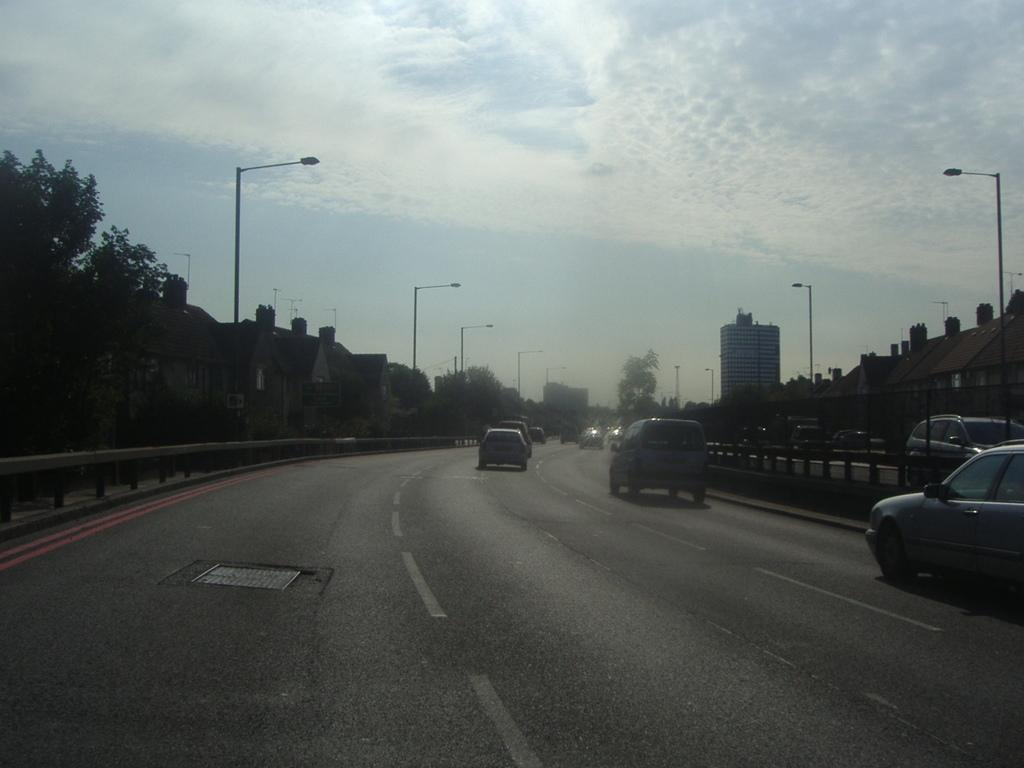What is happening on the road in the image? Vehicles are moving on the road. What can be seen in the background of the image? There are trees, plants, buildings, street lights, vehicles, and the sky visible in the background. Can you describe the setting of the image? The image shows a road with vehicles moving, surrounded by trees, plants, buildings, and street lights in the background, with the sky visible above. How does the lift help the vehicles move in the image? There is no lift present in the image; vehicles are moving on the road without any assistance from a lift. 